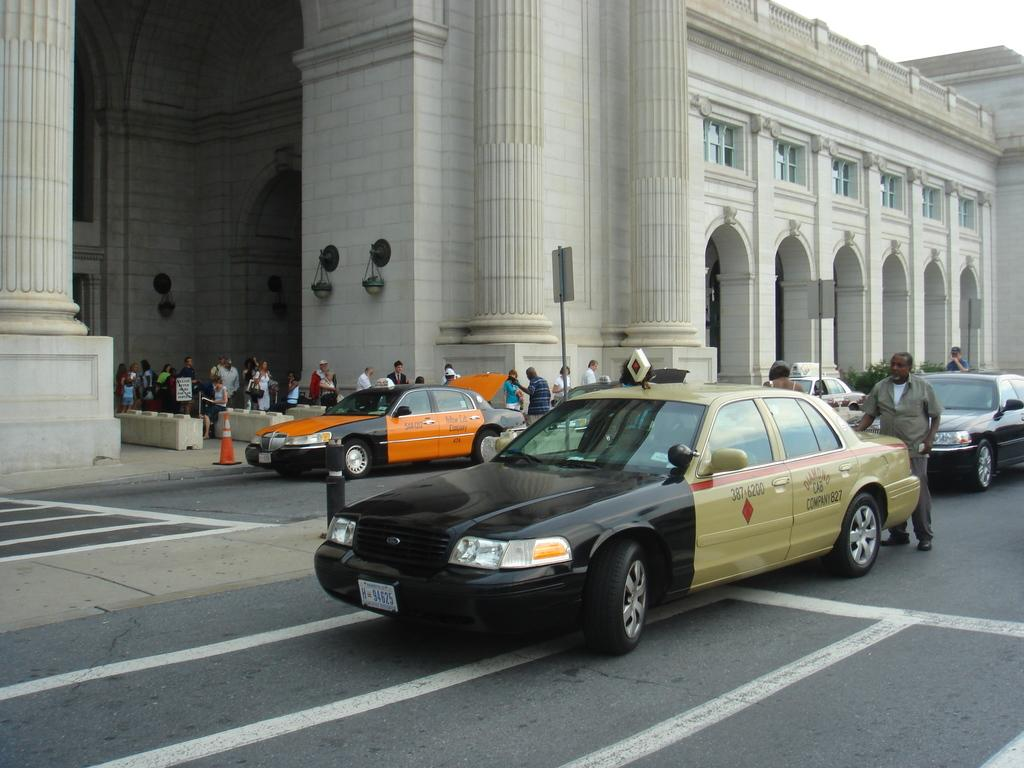What type of view is shown in the image? The image is an outside view. What can be seen on the road in the image? There are cars on the road in the image. What are the people in the background of the image doing? There are people walking in the background of the image. What structure is visible in the top of the image? There is a building visible in the top of the image. How many chickens are running across the road in the image? There are no chickens present in the image; it features cars on the road. What type of plant is growing on the side of the building in the image? There is no plant growing on the side of the building in the image; only the building itself is visible. 